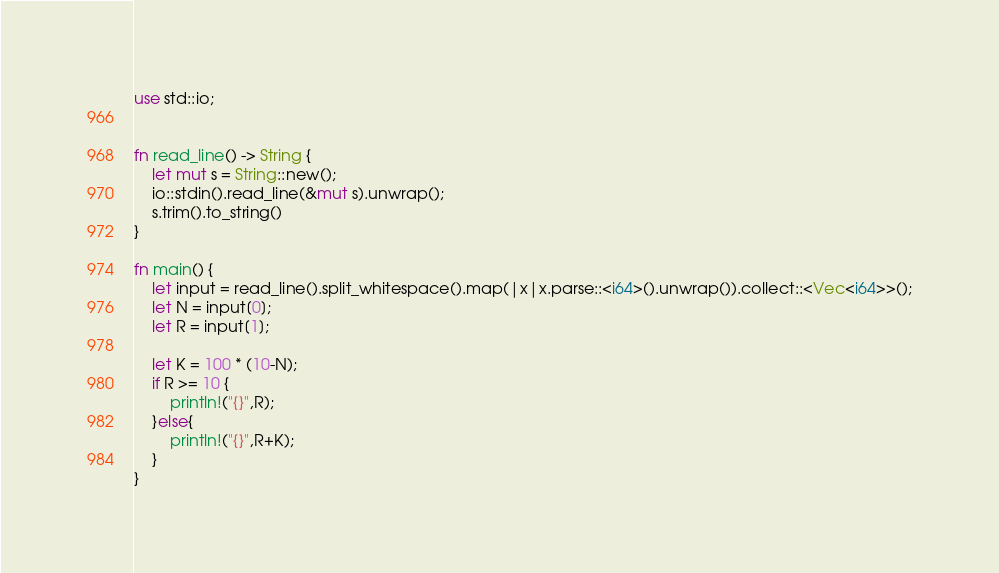<code> <loc_0><loc_0><loc_500><loc_500><_Rust_>use std::io;


fn read_line() -> String {
    let mut s = String::new();
    io::stdin().read_line(&mut s).unwrap();
    s.trim().to_string()
}

fn main() {
    let input = read_line().split_whitespace().map(|x|x.parse::<i64>().unwrap()).collect::<Vec<i64>>();
    let N = input[0];
    let R = input[1];

    let K = 100 * (10-N);
    if R >= 10 {
        println!("{}",R);
    }else{
        println!("{}",R+K);
    }
}</code> 